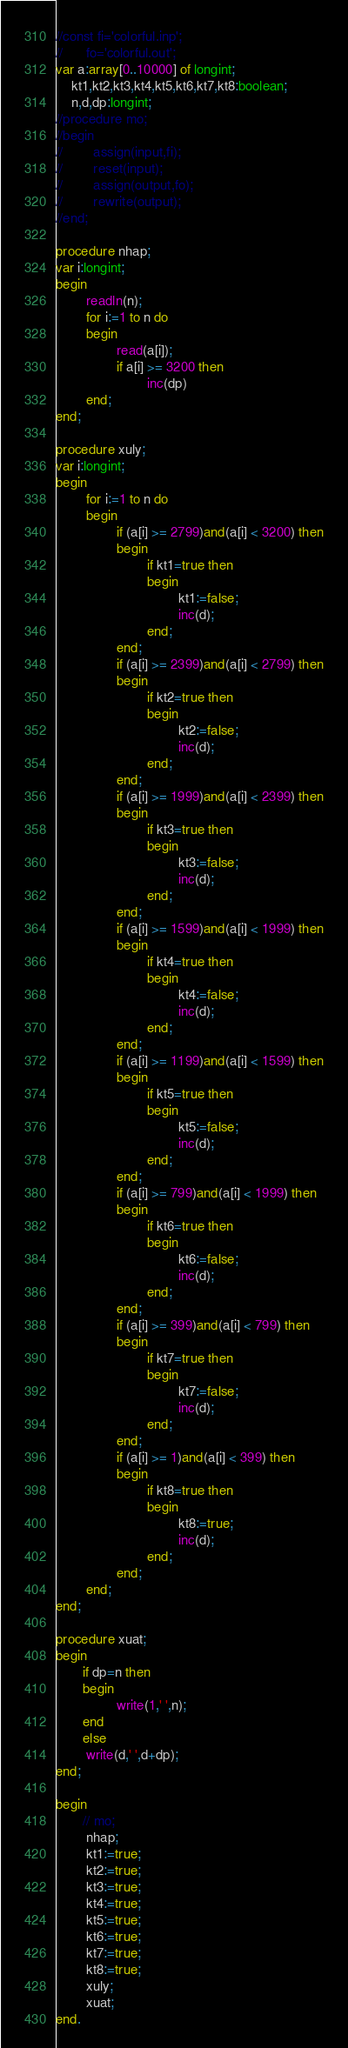<code> <loc_0><loc_0><loc_500><loc_500><_Pascal_>//const fi='colorful.inp';
//      fo='colorful.out';
var a:array[0..10000] of longint;
    kt1,kt2,kt3,kt4,kt5,kt6,kt7,kt8:boolean;
    n,d,dp:longint;
//procedure mo;
//begin
//        assign(input,fi);
//        reset(input);
//        assign(output,fo);
//        rewrite(output);
//end;

procedure nhap;
var i:longint;
begin
        readln(n);
        for i:=1 to n do
        begin
                read(a[i]);
                if a[i] >= 3200 then
                        inc(dp)
        end;
end;

procedure xuly;
var i:longint;
begin
        for i:=1 to n do
        begin
                if (a[i] >= 2799)and(a[i] < 3200) then
                begin
                        if kt1=true then
                        begin
                                kt1:=false;
                                inc(d);
                        end;
                end;
                if (a[i] >= 2399)and(a[i] < 2799) then
                begin
                        if kt2=true then
                        begin
                                kt2:=false;
                                inc(d);
                        end;
                end;
                if (a[i] >= 1999)and(a[i] < 2399) then
                begin
                        if kt3=true then
                        begin
                                kt3:=false;
                                inc(d);
                        end;
                end;
                if (a[i] >= 1599)and(a[i] < 1999) then
                begin
                        if kt4=true then
                        begin
                                kt4:=false;
                                inc(d);
                        end;
                end;
                if (a[i] >= 1199)and(a[i] < 1599) then
                begin
                        if kt5=true then
                        begin
                                kt5:=false;
                                inc(d);
                        end;
                end;
                if (a[i] >= 799)and(a[i] < 1999) then
                begin
                        if kt6=true then
                        begin
                                kt6:=false;
                                inc(d);
                        end;
                end;
                if (a[i] >= 399)and(a[i] < 799) then
                begin
                        if kt7=true then
                        begin
                                kt7:=false;
                                inc(d);
                        end;
                end;
                if (a[i] >= 1)and(a[i] < 399) then
                begin
                        if kt8=true then
                        begin
                                kt8:=true;
                                inc(d);
                        end;
                end;
        end;
end;

procedure xuat;
begin
       if dp=n then
       begin
                write(1,' ',n);
       end
       else
        write(d,' ',d+dp);
end;

begin
       // mo;
        nhap;
        kt1:=true;
        kt2:=true;
        kt3:=true;
        kt4:=true;
        kt5:=true;
        kt6:=true;
        kt7:=true;
        kt8:=true;
        xuly;
        xuat;
end.
</code> 